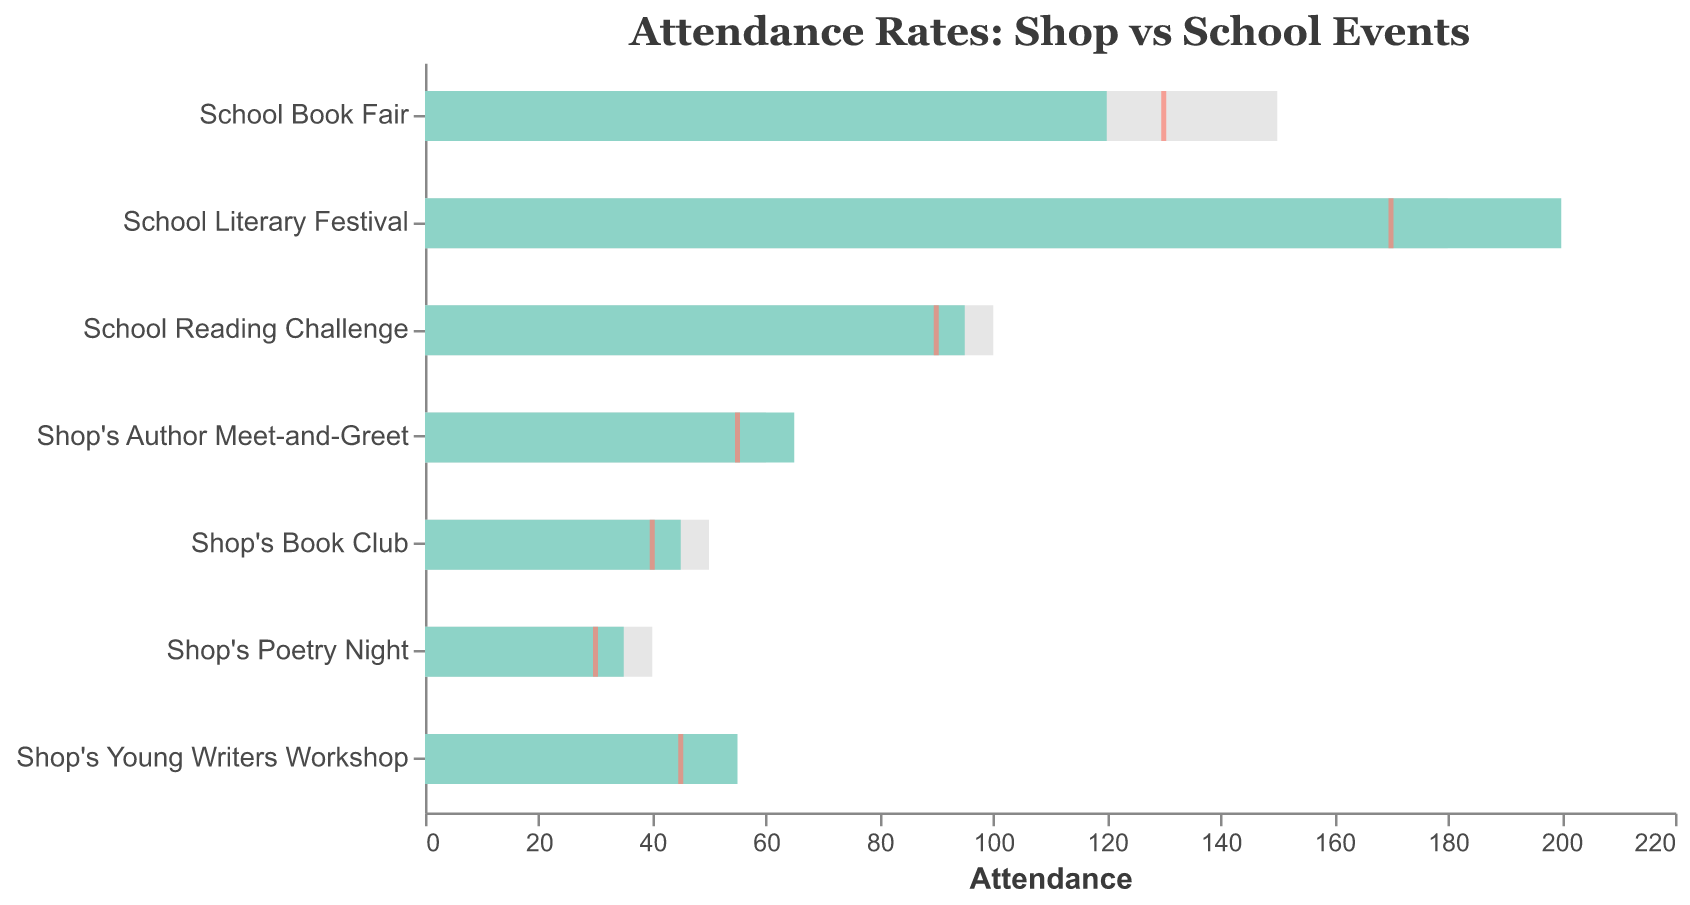How many events have an actual attendance that exceeds the target attendance? To answer this, identify each event's actual attendance and compare it to the target attendance. The Shop's Author Meet-and-Greet and Shop's Young Writers Workshop have higher actual attendance than the target.
Answer: 2 Which event has the highest average attendance? Look for the event with the maximum value in the average attendance category, which is the School Literary Festival with an average of 170 attendees.
Answer: School Literary Festival What is the difference in actual attendance between the School Literary Festival and School Book Fair? The actual attendance at the School Literary Festival is 200, and at the School Book Fair, it's 120. So, the difference is 200 - 120.
Answer: 80 Which shop event has the largest difference between actual and target attendance? Evaluate the absolute difference between actual and target attendance for each shop event. The Shop's Author Meet-and-Greet has the largest difference (65 - 60 = 5).
Answer: Shop's Author Meet-and-Greet What's the median actual attendance of the Shop's events? Arrange the actual attendance figures for the shop events (45, 65, 35, 55). Find the middle value or average of the two central values (45 and 55).
Answer: 50 Do any school events have actual attendance below the average for that event? Compare the actual attendance with the average attendance for each school event. None of the school events have actual attendance below their respective averages.
Answer: No Which event has the lowest target attendance, and what is that value? Identify the event with the smallest figure in the target attendance category. The Shop's Poetry Night has the lowest target attendance of 40.
Answer: Shop's Poetry Night Compare the target attendance of the two most attended events. Which has a higher target attendance and by how much? Compare the target attendance of the School Literary Festival (180) and the School Book Fair (150). The School Literary Festival has a higher target attendance by 30.
Answer: School Literary Festival, 30 What is the overall average actual attendance across all events? Sum the actual attendance of all events (45 + 120 + 65 + 200 + 35 + 95 + 55 = 615). Divide by the number of events (7).
Answer: 87.86 Which shop event has actual attendance closest to its average attendance? Look at the difference between actual and average attendance for each shop event and find the smallest difference. The Shop's Poetry Night has the closest actual attendance to its average (35 - 30 = 5).
Answer: Shop's Poetry Night 